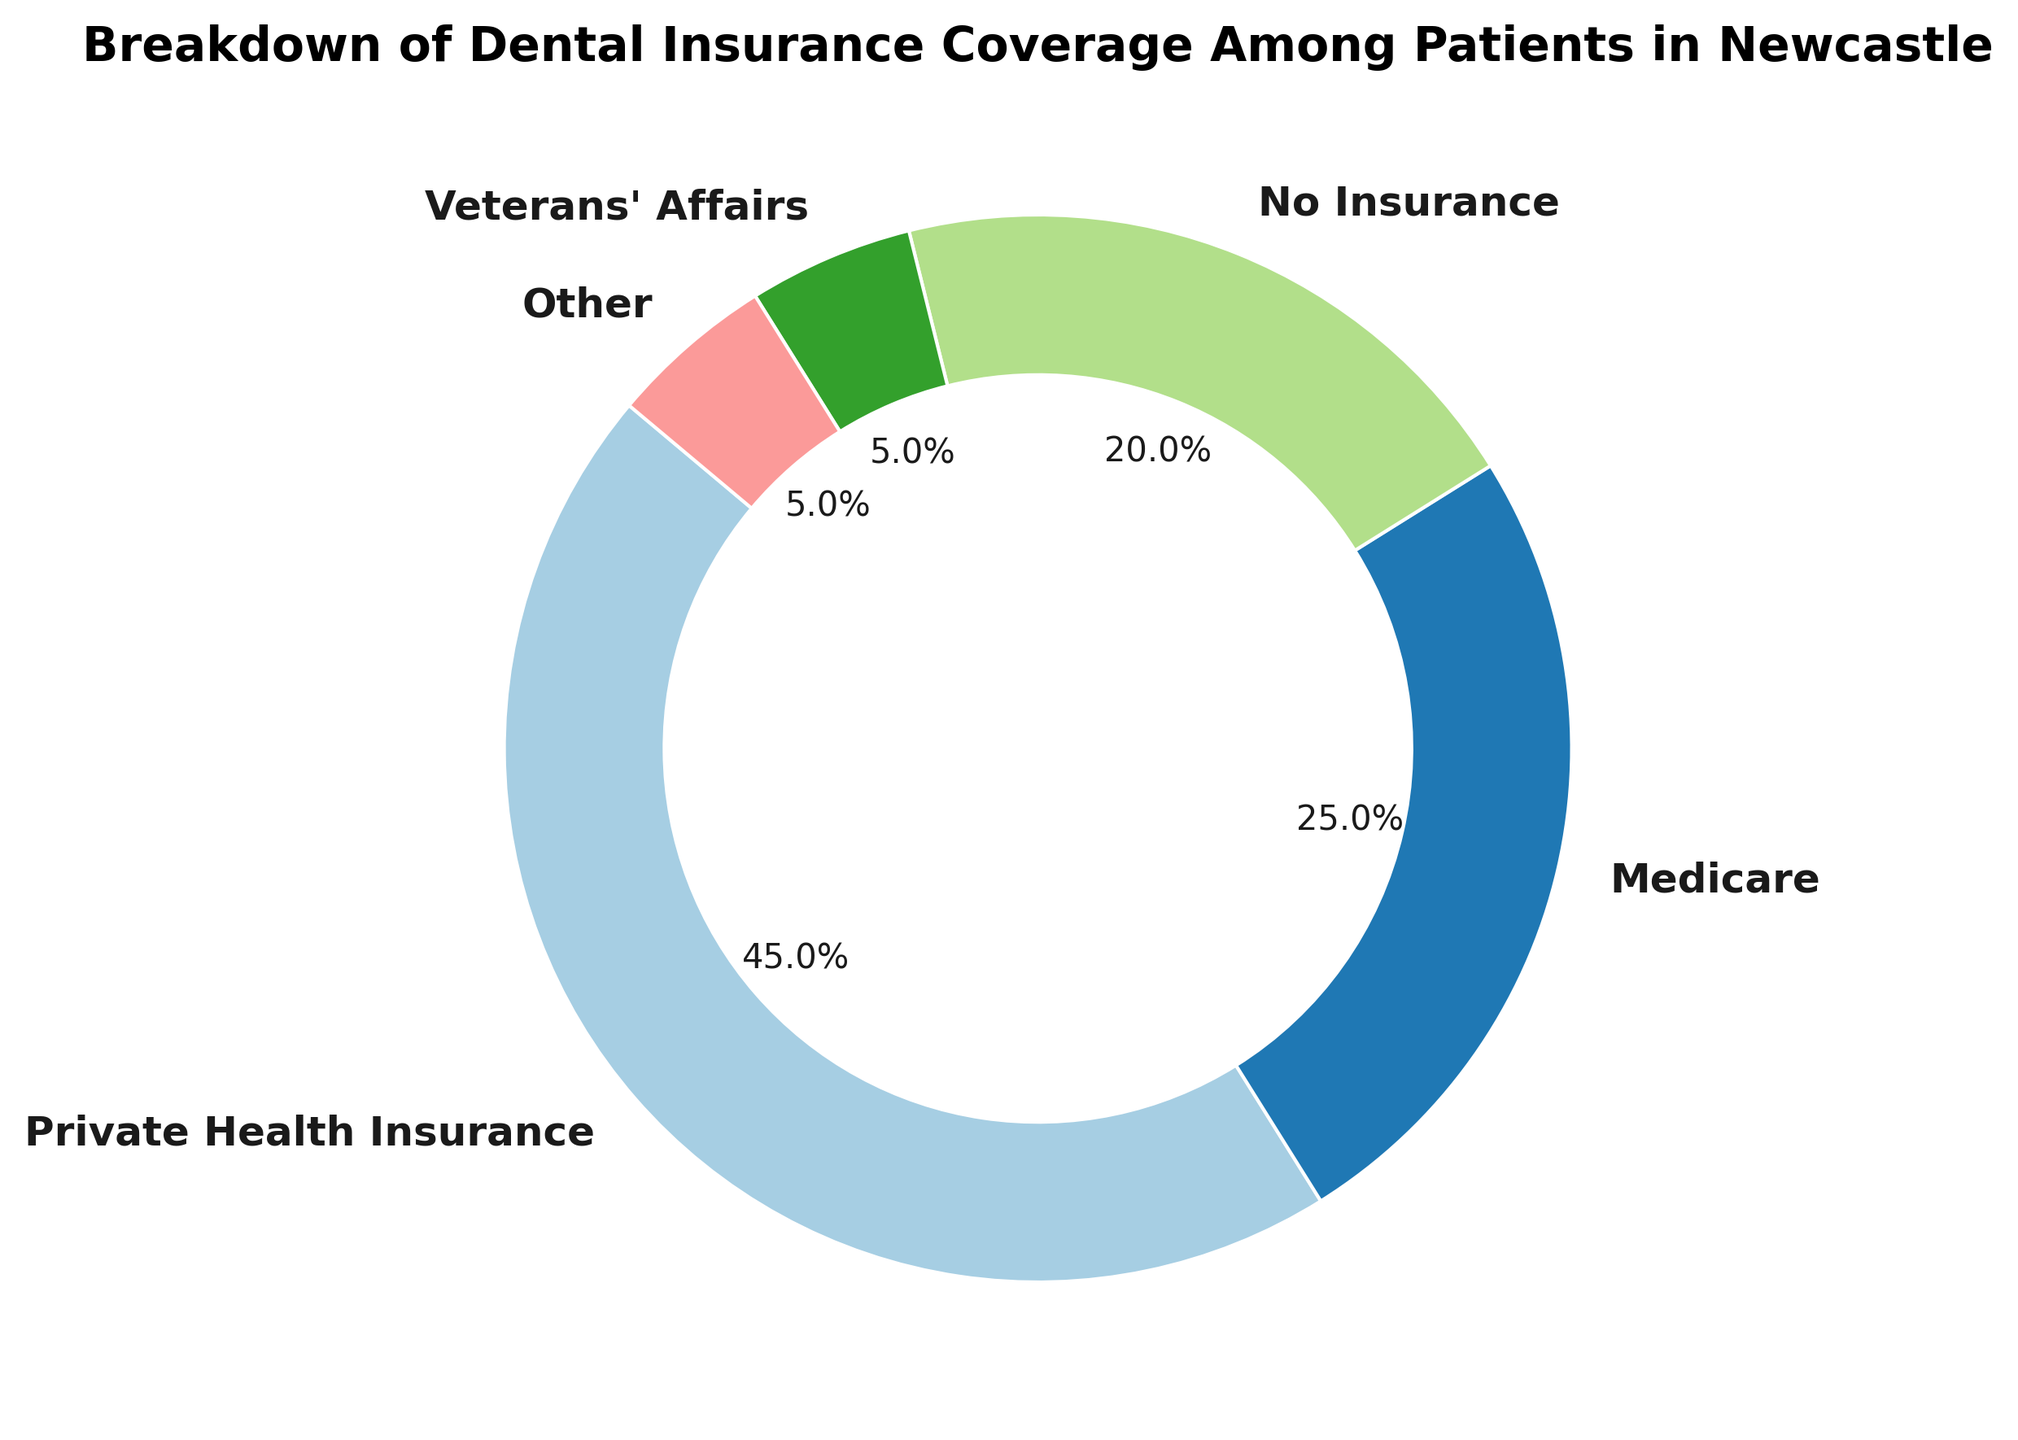What percentage of patients are covered by Private Health Insurance? To determine this, locate the slice representing "Private Health Insurance" and check the percentage indicated on that slice. It shows 45%.
Answer: 45% How many types of insurance coverages are shown in the chart? To find the total number of insurance types, count the labels around the pie chart. There are 5 labels: Private Health Insurance, Medicare, No Insurance, Veterans' Affairs, and Other.
Answer: 5 What is the sum of the percentages for Medicare and No Insurance? Add the percentage of Medicare (25%) to the percentage of No Insurance (20%). The sum is 25% + 20% = 45%.
Answer: 45% Which insurance type covers more patients, Veterans' Affairs or Other? Compare the percentages of the two slices. Both Veterans' Affairs and Other are labeled as 5%, indicating they cover the same percentage of patients.
Answer: They cover the same percentage What is the difference in percentage between patients with Private Health Insurance and those without any insurance? Subtract the percentage of No Insurance (20%) from the percentage of Private Health Insurance (45%). The difference is 45% - 20% = 25%.
Answer: 25% What is the combined percentage of patients who either have Veterans' Affairs or Other insurance? Sum the percentages of Veterans' Affairs (5%) and Other (5%). The combined percentage is 5% + 5% = 10%.
Answer: 10% Is the segment for Medicare larger than the segment for No Insurance? Compare the sizes of the slices: Medicare is 25% and No Insurance is 20%. Medicare's segment is indeed larger.
Answer: Yes What color represents the No Insurance category in the pie chart? Identify the slice labeled "No Insurance" and observe its color.
Answer: (The color details cannot be answered as they depend on the matplotlib color map which is not detailed) What is the average percentage of patients across all insurance types? To find the average, sum the percentages of all five categories and divide by 5. Sum = 45% + 25% + 20% + 5% + 5% = 100%. The average is 100% / 5 = 20%.
Answer: 20% If the population of Newcastle is 10,000 patients, how many have Medicare coverage? Calculate the number by taking 25% (percentage for Medicare) of 10,000. The calculation is 25% * 10,000 = 0.25 * 10,000 = 2,500.
Answer: 2,500 